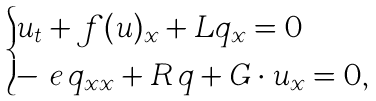<formula> <loc_0><loc_0><loc_500><loc_500>\begin{cases} u _ { t } + f ( u ) _ { x } + L q _ { x } = 0 & \\ - \ e \, q _ { x x } + R \, q + G \cdot u _ { x } = 0 , & \end{cases}</formula> 